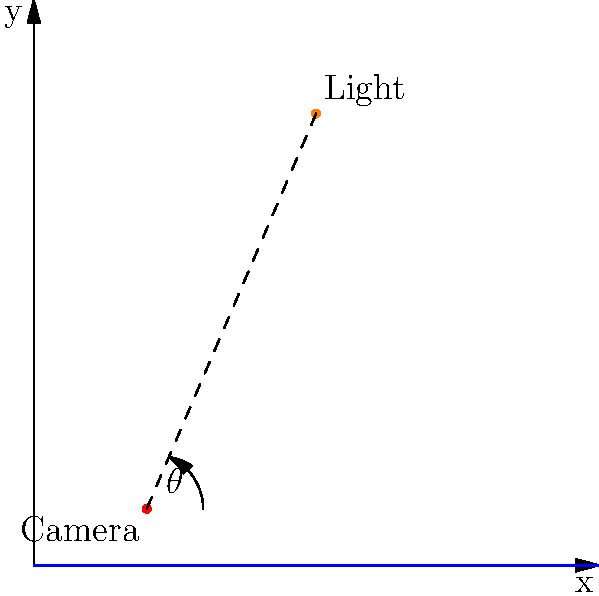As a photojournalist capturing Angelina Jolie's humanitarian work, you need to determine the optimal angle of elevation for your light source to achieve the best lighting. Given that your camera is positioned at (2, 1) and the light source is at (5, 8) on a coordinate plane where each unit represents 1 meter, find the angle of elevation $\theta$ (in degrees) that maximizes the lighting effect. Use the formula $I = \frac{k \cos \theta}{r^2}$, where $I$ is the light intensity, $k$ is a constant, $r$ is the distance between the light source and the camera, and $\theta$ is the angle of elevation. Round your answer to the nearest degree. To solve this problem, we'll follow these steps:

1) First, let's find the distance $r$ between the camera and the light source:
   $r = \sqrt{(5-2)^2 + (8-1)^2} = \sqrt{3^2 + 7^2} = \sqrt{58}$ meters

2) Now, let's express $\cos \theta$ in terms of $x$ and $y$ coordinates:
   $\cos \theta = \frac{x}{\sqrt{x^2 + y^2}} = \frac{3}{\sqrt{58}}$

3) The light intensity formula is $I = \frac{k \cos \theta}{r^2}$. Substituting our values:
   $I = \frac{k \cdot \frac{3}{\sqrt{58}}}{58} = \frac{3k}{58\sqrt{58}}$

4) To find the optimal angle, we need to maximize this expression. Since $k$ and 58 are constants, we just need to maximize $\cos \theta$.

5) The maximum value of cosine is 1, which occurs when $\theta = 0°$. However, in this case, we're constrained by the physical setup.

6) The actual angle $\theta$ can be calculated using the arctangent function:
   $\theta = \arctan(\frac{y}{x}) = \arctan(\frac{7}{3}) \approx 66.80°$

7) Rounding to the nearest degree gives us 67°.

This angle represents the optimal elevation for the light source given the physical constraints of the setup.
Answer: 67° 